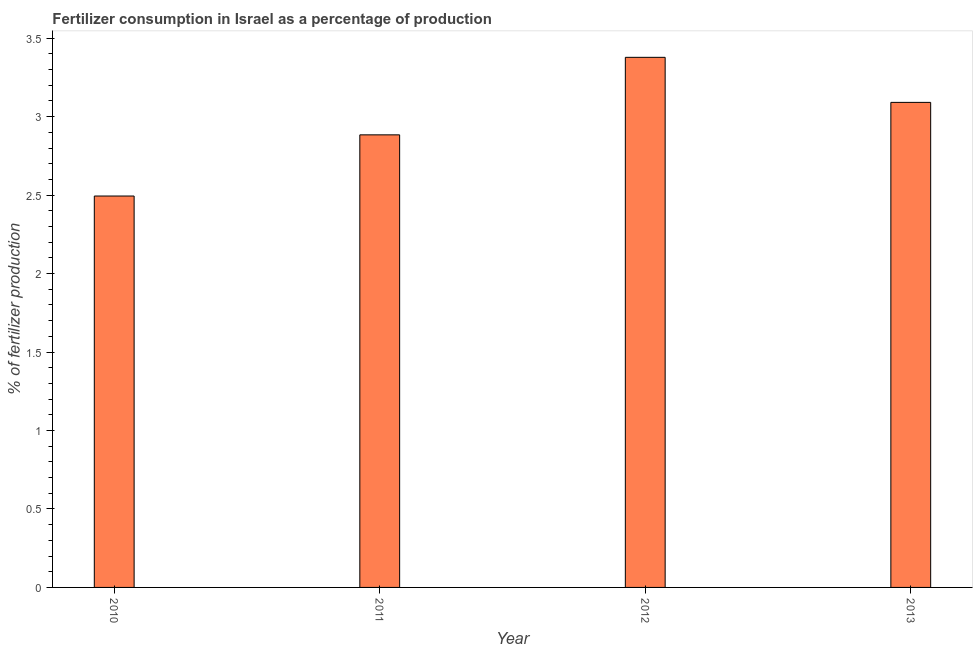Does the graph contain grids?
Keep it short and to the point. No. What is the title of the graph?
Ensure brevity in your answer.  Fertilizer consumption in Israel as a percentage of production. What is the label or title of the Y-axis?
Provide a short and direct response. % of fertilizer production. What is the amount of fertilizer consumption in 2012?
Ensure brevity in your answer.  3.38. Across all years, what is the maximum amount of fertilizer consumption?
Provide a short and direct response. 3.38. Across all years, what is the minimum amount of fertilizer consumption?
Offer a very short reply. 2.49. In which year was the amount of fertilizer consumption maximum?
Offer a terse response. 2012. What is the sum of the amount of fertilizer consumption?
Keep it short and to the point. 11.85. What is the difference between the amount of fertilizer consumption in 2010 and 2012?
Your answer should be very brief. -0.88. What is the average amount of fertilizer consumption per year?
Make the answer very short. 2.96. What is the median amount of fertilizer consumption?
Provide a short and direct response. 2.99. What is the ratio of the amount of fertilizer consumption in 2010 to that in 2011?
Ensure brevity in your answer.  0.86. What is the difference between the highest and the second highest amount of fertilizer consumption?
Make the answer very short. 0.29. Is the sum of the amount of fertilizer consumption in 2011 and 2013 greater than the maximum amount of fertilizer consumption across all years?
Provide a short and direct response. Yes. How many bars are there?
Make the answer very short. 4. How many years are there in the graph?
Keep it short and to the point. 4. What is the difference between two consecutive major ticks on the Y-axis?
Provide a succinct answer. 0.5. What is the % of fertilizer production in 2010?
Offer a terse response. 2.49. What is the % of fertilizer production of 2011?
Provide a succinct answer. 2.88. What is the % of fertilizer production in 2012?
Keep it short and to the point. 3.38. What is the % of fertilizer production of 2013?
Your answer should be very brief. 3.09. What is the difference between the % of fertilizer production in 2010 and 2011?
Keep it short and to the point. -0.39. What is the difference between the % of fertilizer production in 2010 and 2012?
Make the answer very short. -0.88. What is the difference between the % of fertilizer production in 2010 and 2013?
Provide a short and direct response. -0.6. What is the difference between the % of fertilizer production in 2011 and 2012?
Keep it short and to the point. -0.49. What is the difference between the % of fertilizer production in 2011 and 2013?
Your answer should be very brief. -0.21. What is the difference between the % of fertilizer production in 2012 and 2013?
Ensure brevity in your answer.  0.29. What is the ratio of the % of fertilizer production in 2010 to that in 2011?
Ensure brevity in your answer.  0.86. What is the ratio of the % of fertilizer production in 2010 to that in 2012?
Ensure brevity in your answer.  0.74. What is the ratio of the % of fertilizer production in 2010 to that in 2013?
Offer a very short reply. 0.81. What is the ratio of the % of fertilizer production in 2011 to that in 2012?
Provide a short and direct response. 0.85. What is the ratio of the % of fertilizer production in 2011 to that in 2013?
Keep it short and to the point. 0.93. What is the ratio of the % of fertilizer production in 2012 to that in 2013?
Give a very brief answer. 1.09. 